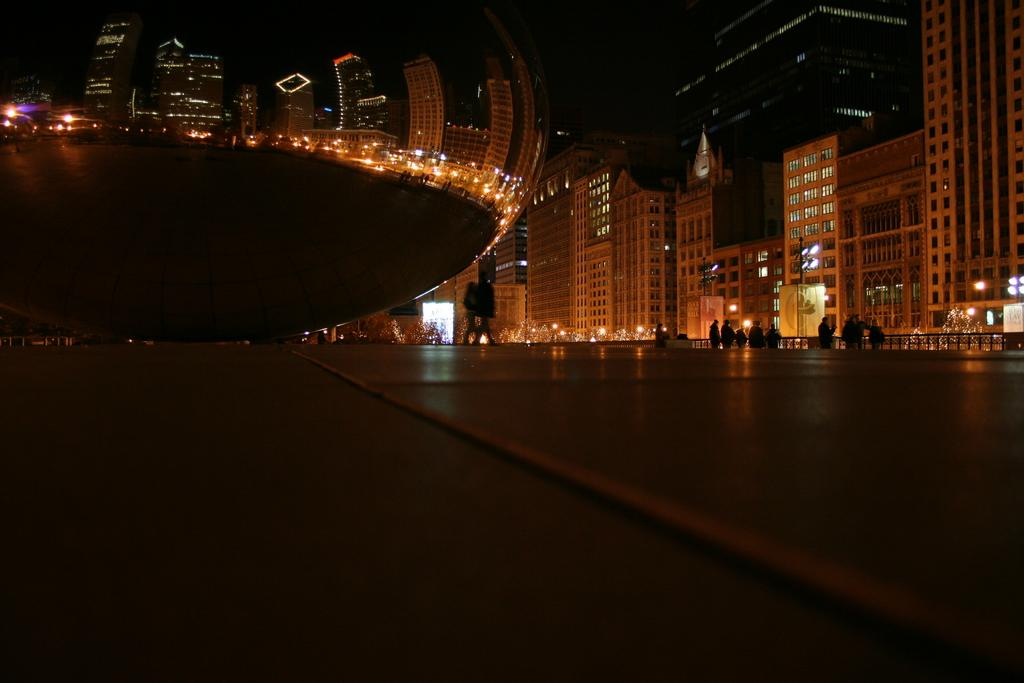What is the main subject in the center of the image? There are persons in the center of the image. What type of structures can be seen on the right side of the image? There are buildings on the right side of the image. What is the reflection of on the left side of the image? The reflection of the buildings can be seen on the left side of the image, likely on a mirror. Can you tell me how many nerves are visible in the image? There are no nerves present in the image; it features persons and buildings. What type of heart can be seen in the image? There is no heart present in the image. 